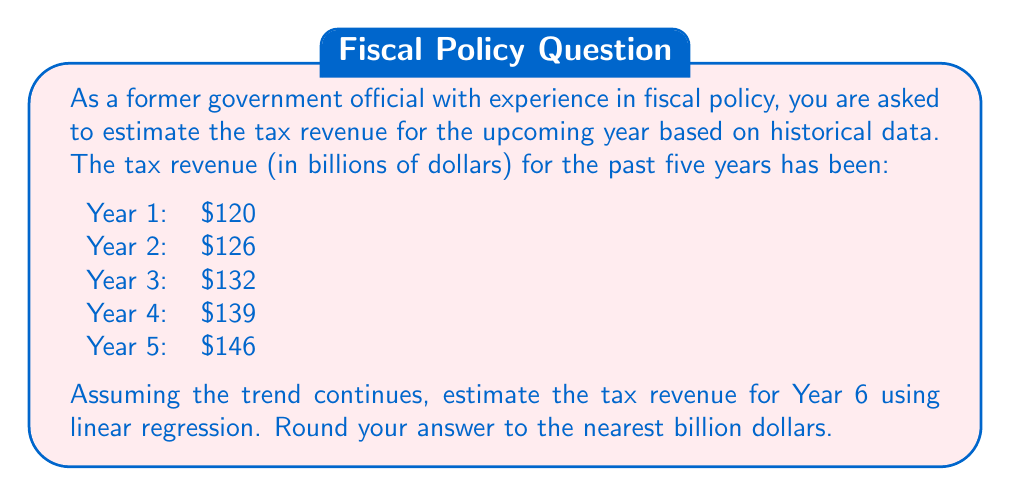Provide a solution to this math problem. To estimate the tax revenue for Year 6 using linear regression, we'll follow these steps:

1) First, let's set up our data points:
   x (year): 1, 2, 3, 4, 5
   y (revenue): 120, 126, 132, 139, 146

2) We need to calculate the following sums:
   $\sum x = 1 + 2 + 3 + 4 + 5 = 15$
   $\sum y = 120 + 126 + 132 + 139 + 146 = 663$
   $\sum xy = (1)(120) + (2)(126) + (3)(132) + (4)(139) + (5)(146) = 2061$
   $\sum x^2 = 1^2 + 2^2 + 3^2 + 4^2 + 5^2 = 55$
   $n = 5$ (number of data points)

3) Now we can use the linear regression formula to find the slope (m) and y-intercept (b):

   $m = \frac{n\sum xy - \sum x \sum y}{n\sum x^2 - (\sum x)^2}$

   $m = \frac{5(2061) - (15)(663)}{5(55) - (15)^2} = \frac{10305 - 9945}{275 - 225} = \frac{360}{50} = 7.2$

   $b = \frac{\sum y - m\sum x}{n} = \frac{663 - 7.2(15)}{5} = \frac{663 - 108}{5} = 111$

4) Our linear regression equation is:
   $y = 7.2x + 111$

5) To estimate Year 6, we plug in x = 6:
   $y = 7.2(6) + 111 = 43.2 + 111 = 154.2$

6) Rounding to the nearest billion:
   $154.2 billion ≈ 154 billion$
Answer: $154 billion 